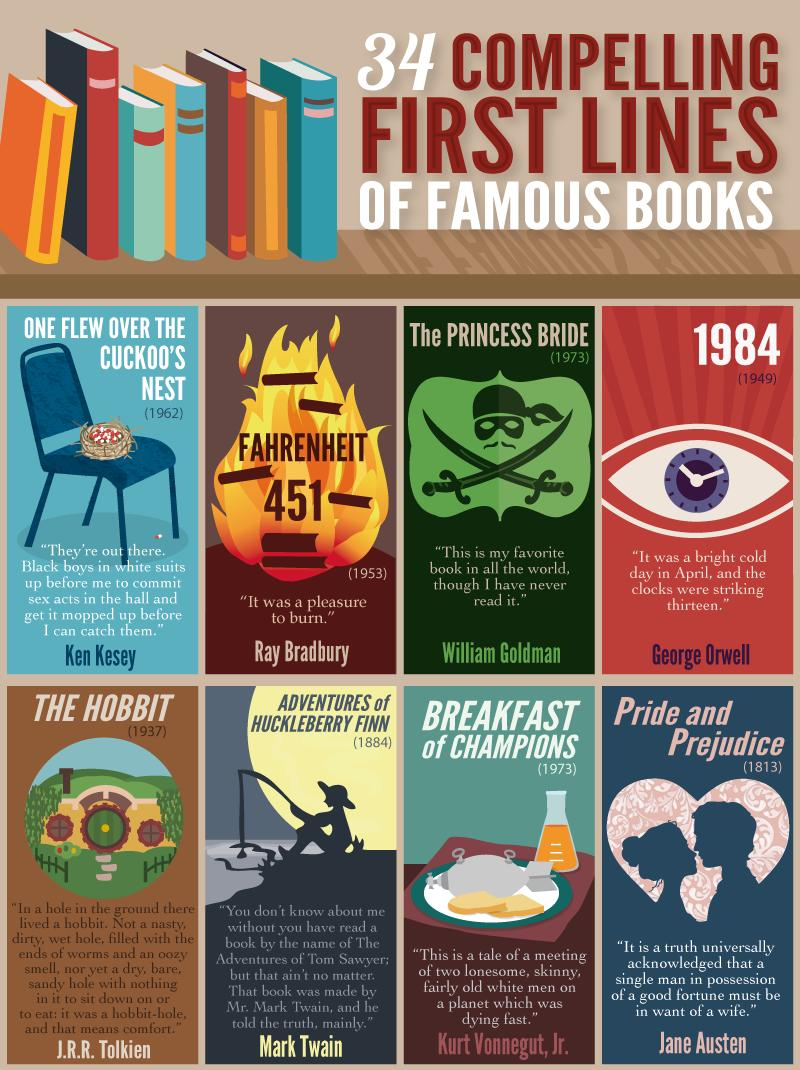Highlight a few significant elements in this photo. J.R.R. Tolkien is the author of 'THE HOBBIT'. It is a pleasure to declare that the first line of 'FAHRENHEIT 451' is “It was a pleasure to burn.”. Jane Austen is the author of "Pride and Prejudice. The book titled "The Princess Bride" was published in 1973. The book titled 'Breakfast of Champions' was published in 1973. 